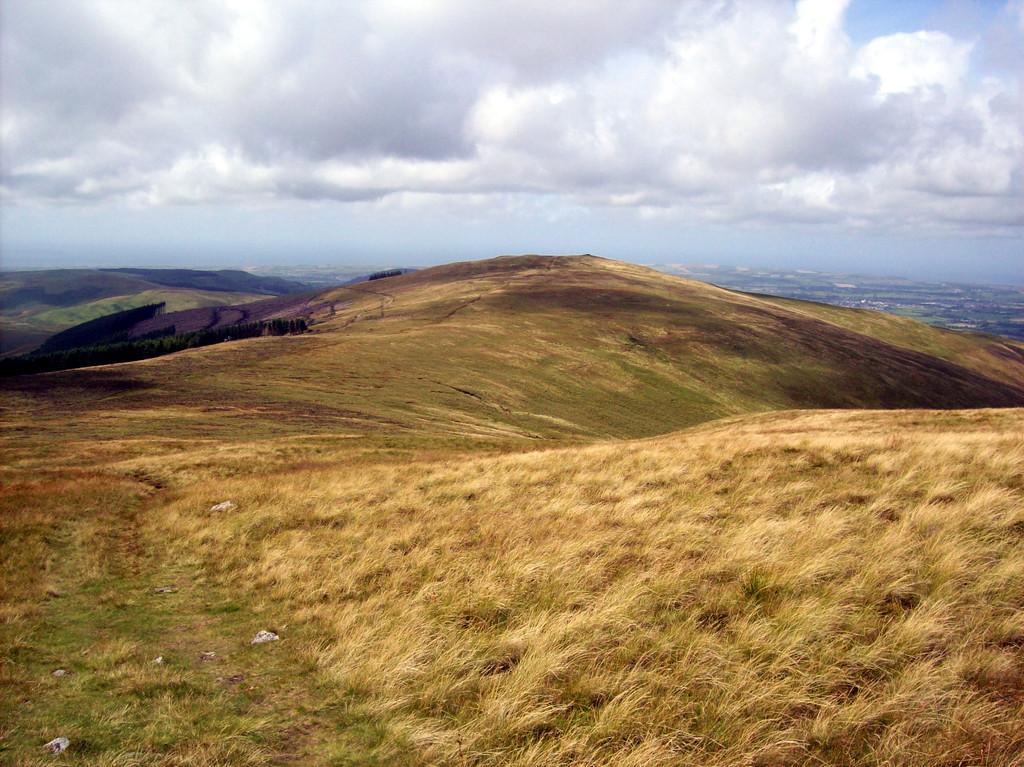In one or two sentences, can you explain what this image depicts? This is an outside view. At the bottom of the image I can see the grass on the ground. There are some hills. At the top of the image I can see the sky and clouds. 